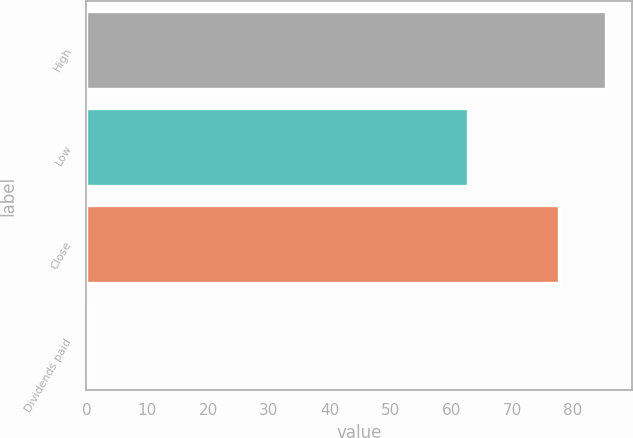<chart> <loc_0><loc_0><loc_500><loc_500><bar_chart><fcel>High<fcel>Low<fcel>Close<fcel>Dividends paid<nl><fcel>85.44<fcel>62.8<fcel>77.67<fcel>0.25<nl></chart> 